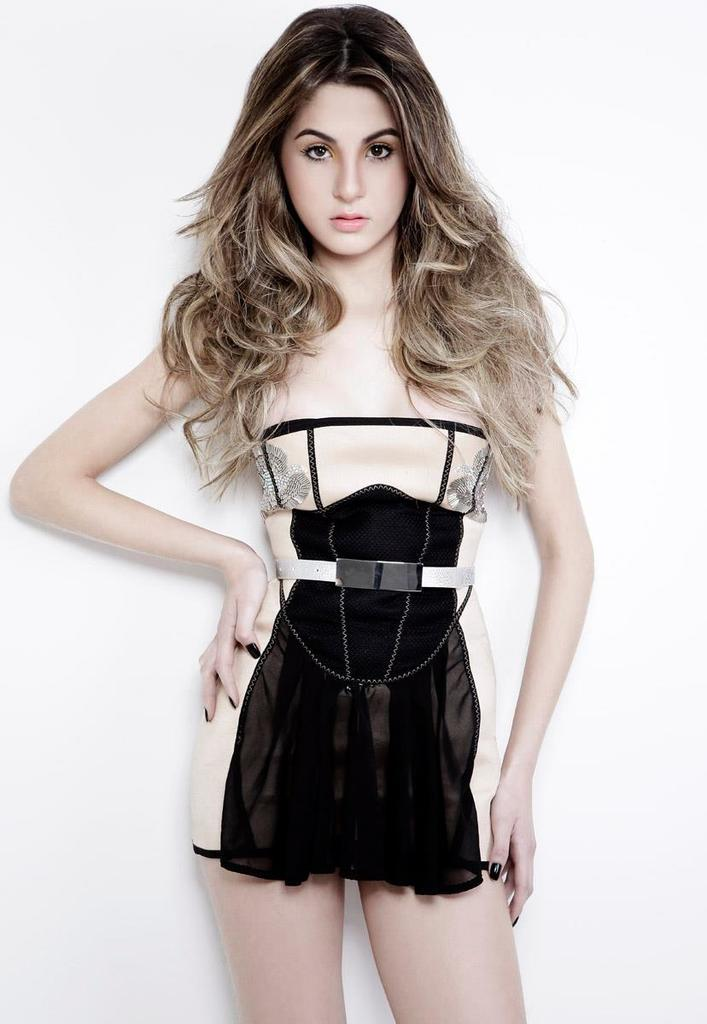Who is the main subject in the image? There is a woman in the image. What is the woman doing in the image? The woman is standing. What is the woman wearing in the image? The woman is wearing a cream and black color dress. What type of toothpaste is the woman using in the image? There is no toothpaste present in the image; the woman is simply standing and wearing a dress. 